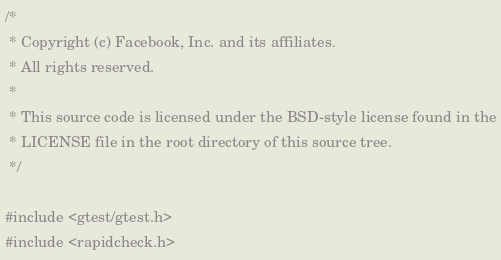<code> <loc_0><loc_0><loc_500><loc_500><_C++_>/*
 * Copyright (c) Facebook, Inc. and its affiliates.
 * All rights reserved.
 *
 * This source code is licensed under the BSD-style license found in the
 * LICENSE file in the root directory of this source tree.
 */

#include <gtest/gtest.h>
#include <rapidcheck.h></code> 